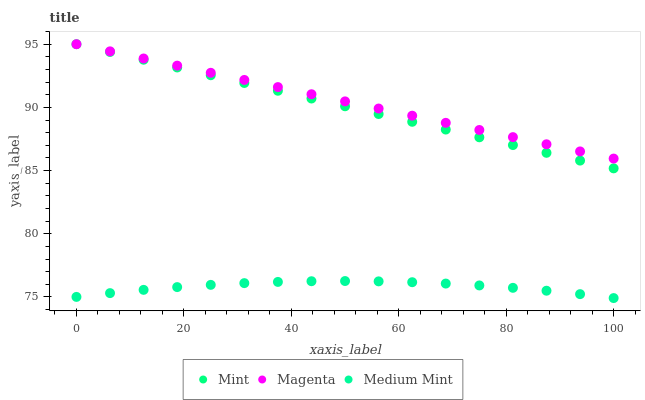Does Medium Mint have the minimum area under the curve?
Answer yes or no. Yes. Does Magenta have the maximum area under the curve?
Answer yes or no. Yes. Does Mint have the minimum area under the curve?
Answer yes or no. No. Does Mint have the maximum area under the curve?
Answer yes or no. No. Is Magenta the smoothest?
Answer yes or no. Yes. Is Medium Mint the roughest?
Answer yes or no. Yes. Is Mint the roughest?
Answer yes or no. No. Does Medium Mint have the lowest value?
Answer yes or no. Yes. Does Mint have the lowest value?
Answer yes or no. No. Does Mint have the highest value?
Answer yes or no. Yes. Is Medium Mint less than Magenta?
Answer yes or no. Yes. Is Magenta greater than Medium Mint?
Answer yes or no. Yes. Does Magenta intersect Mint?
Answer yes or no. Yes. Is Magenta less than Mint?
Answer yes or no. No. Is Magenta greater than Mint?
Answer yes or no. No. Does Medium Mint intersect Magenta?
Answer yes or no. No. 